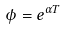<formula> <loc_0><loc_0><loc_500><loc_500>\phi = e ^ { \alpha T }</formula> 